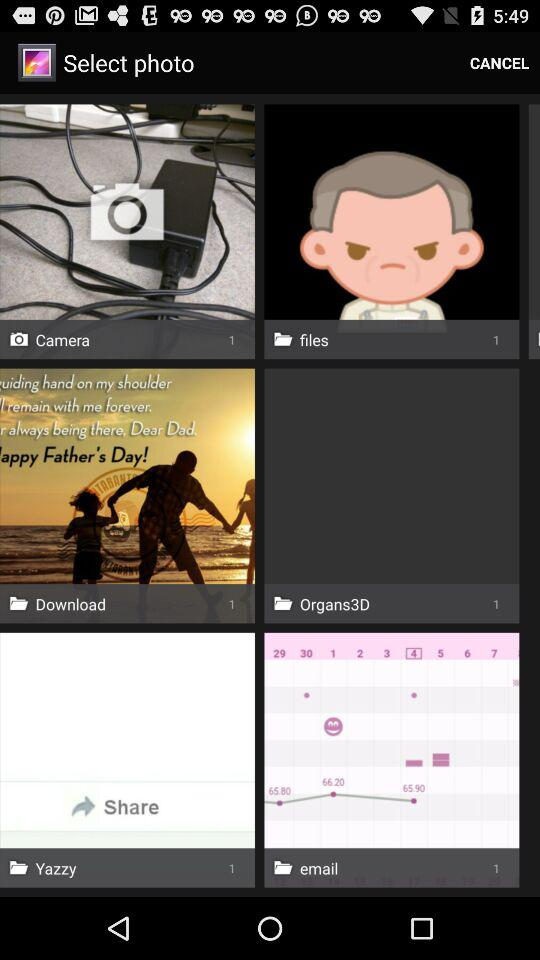How many photos are there in the "Download" folder? There is 1 photo. 